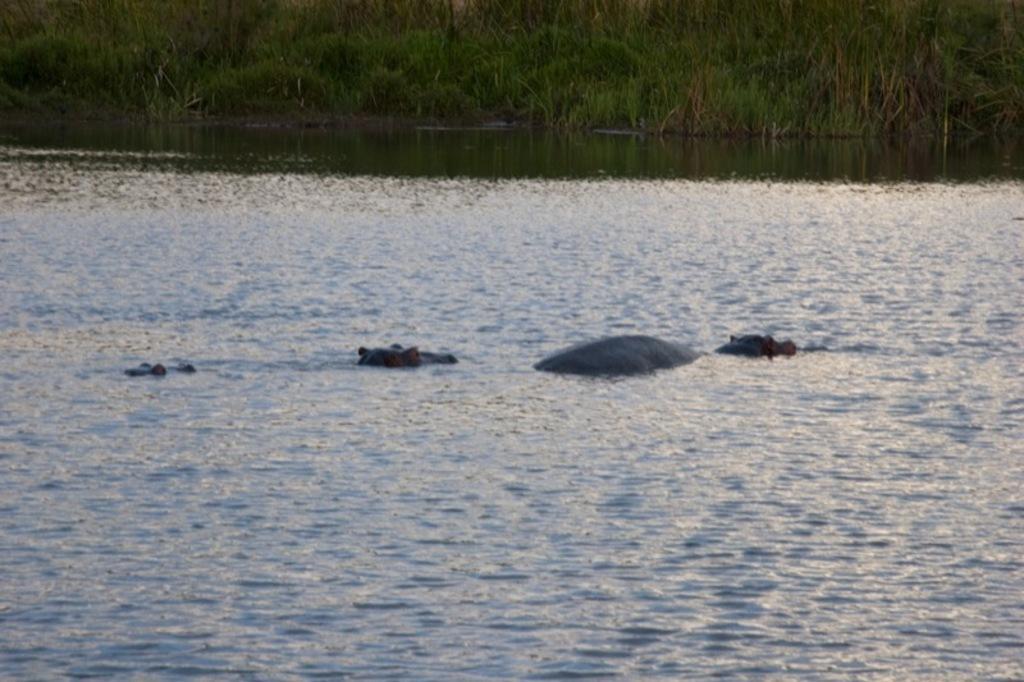Please provide a concise description of this image. In this picture we can see some animals in the water. In the background we can see green grass. 